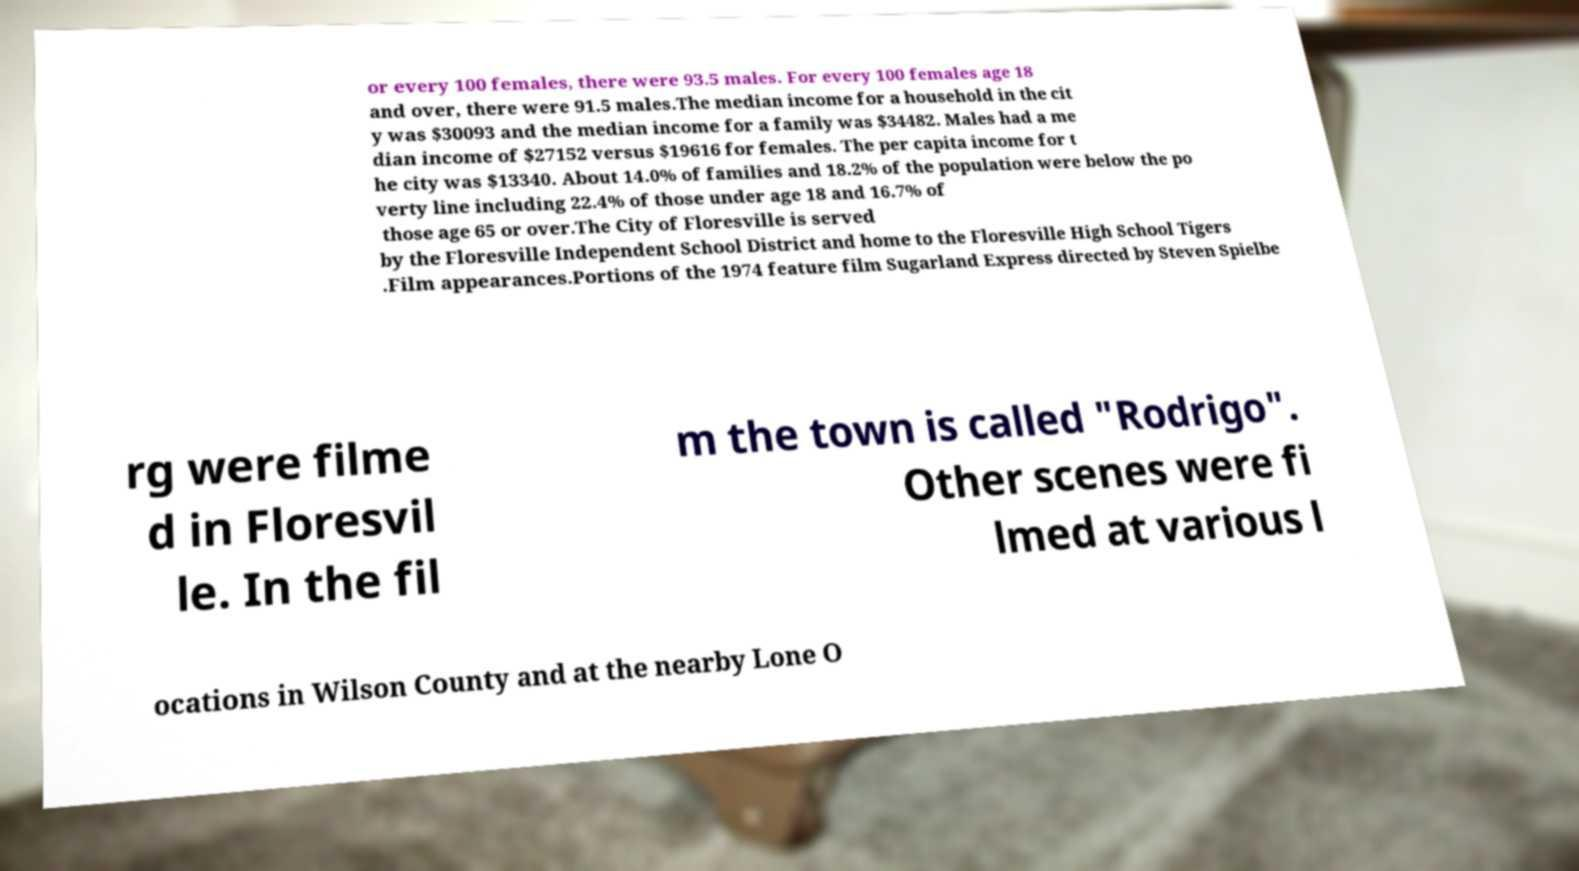Can you read and provide the text displayed in the image?This photo seems to have some interesting text. Can you extract and type it out for me? or every 100 females, there were 93.5 males. For every 100 females age 18 and over, there were 91.5 males.The median income for a household in the cit y was $30093 and the median income for a family was $34482. Males had a me dian income of $27152 versus $19616 for females. The per capita income for t he city was $13340. About 14.0% of families and 18.2% of the population were below the po verty line including 22.4% of those under age 18 and 16.7% of those age 65 or over.The City of Floresville is served by the Floresville Independent School District and home to the Floresville High School Tigers .Film appearances.Portions of the 1974 feature film Sugarland Express directed by Steven Spielbe rg were filme d in Floresvil le. In the fil m the town is called "Rodrigo". Other scenes were fi lmed at various l ocations in Wilson County and at the nearby Lone O 